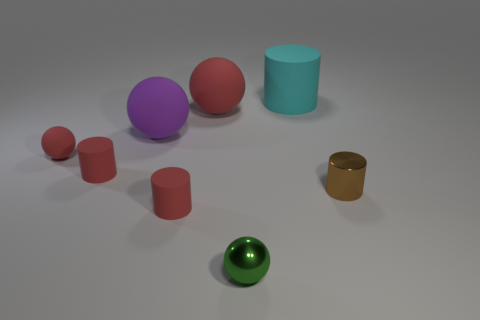Subtract all matte cylinders. How many cylinders are left? 1 Add 2 red matte spheres. How many objects exist? 10 Subtract all purple spheres. How many spheres are left? 3 Subtract 2 balls. How many balls are left? 2 Subtract all yellow cylinders. Subtract all brown blocks. How many cylinders are left? 4 Subtract all gray balls. How many red cylinders are left? 2 Subtract all small green shiny spheres. Subtract all green metallic things. How many objects are left? 6 Add 2 large matte cylinders. How many large matte cylinders are left? 3 Add 2 tiny cylinders. How many tiny cylinders exist? 5 Subtract 1 green spheres. How many objects are left? 7 